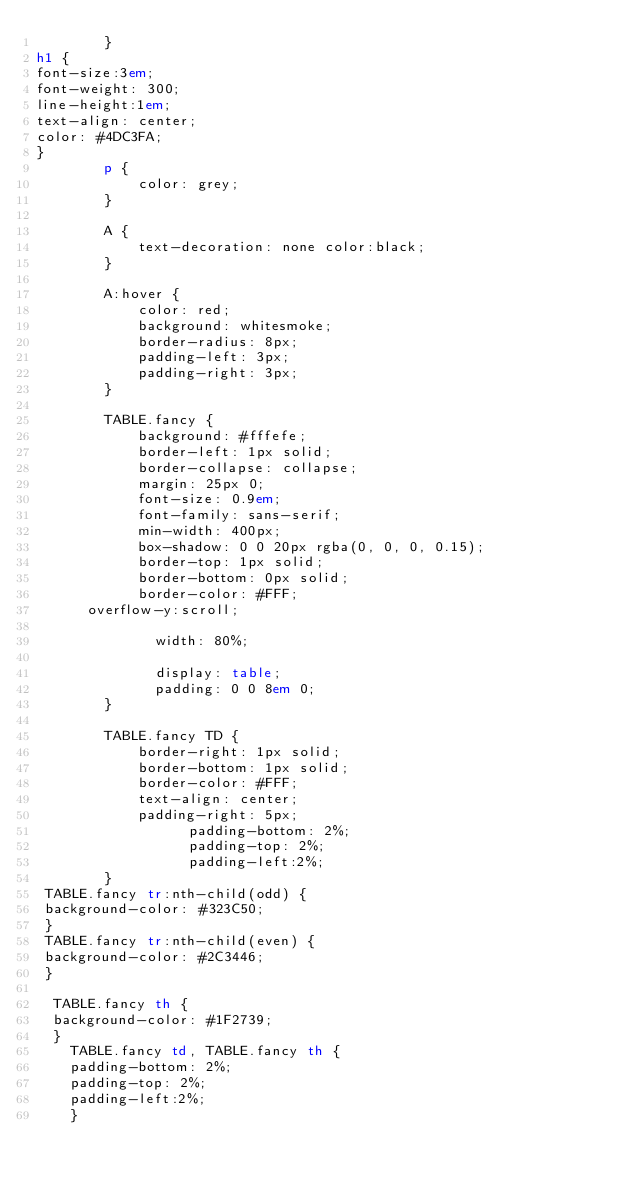<code> <loc_0><loc_0><loc_500><loc_500><_HTML_>        }
h1 {
font-size:3em;
font-weight: 300;
line-height:1em;
text-align: center;
color: #4DC3FA;
}
        p {
            color: grey;
        }

        A {
            text-decoration: none color:black;
        }

        A:hover {
            color: red;
            background: whitesmoke;
            border-radius: 8px;
            padding-left: 3px;
            padding-right: 3px;
        }

        TABLE.fancy {
            background: #fffefe;
            border-left: 1px solid;
            border-collapse: collapse;
            margin: 25px 0;
            font-size: 0.9em;
            font-family: sans-serif;
            min-width: 400px;
            box-shadow: 0 0 20px rgba(0, 0, 0, 0.15);
            border-top: 1px solid;
            border-bottom: 0px solid;
            border-color: #FFF;
      overflow-y:scroll;
       
           	  width: 80%;
       
           	  display: table;
           	  padding: 0 0 8em 0;
        }

        TABLE.fancy TD {
            border-right: 1px solid;
            border-bottom: 1px solid;
            border-color: #FFF;
            text-align: center;
            padding-right: 5px;
            	  padding-bottom: 2%;
            	  padding-top: 2%;
            	  padding-left:2%;
        }
 TABLE.fancy tr:nth-child(odd) {
 background-color: #323C50;
 }
 TABLE.fancy tr:nth-child(even) {
 background-color: #2C3446;
 }
 
  TABLE.fancy th {
  background-color: #1F2739;
  }
    TABLE.fancy td, TABLE.fancy th {
    padding-bottom: 2%;
    padding-top: 2%;
    padding-left:2%;
    }</code> 